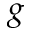Convert formula to latex. <formula><loc_0><loc_0><loc_500><loc_500>g</formula> 